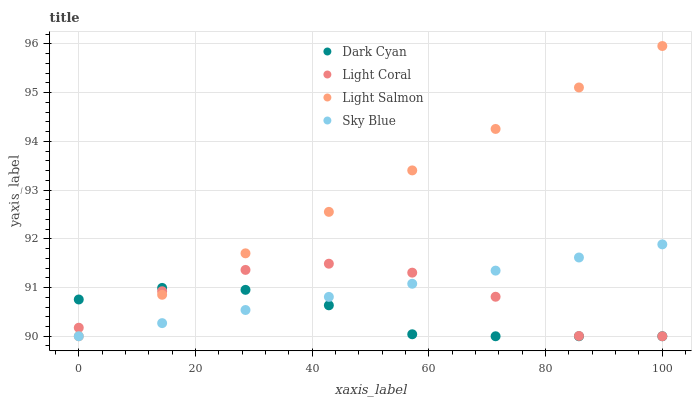Does Dark Cyan have the minimum area under the curve?
Answer yes or no. Yes. Does Light Salmon have the maximum area under the curve?
Answer yes or no. Yes. Does Light Coral have the minimum area under the curve?
Answer yes or no. No. Does Light Coral have the maximum area under the curve?
Answer yes or no. No. Is Sky Blue the smoothest?
Answer yes or no. Yes. Is Light Coral the roughest?
Answer yes or no. Yes. Is Light Salmon the smoothest?
Answer yes or no. No. Is Light Salmon the roughest?
Answer yes or no. No. Does Dark Cyan have the lowest value?
Answer yes or no. Yes. Does Light Salmon have the highest value?
Answer yes or no. Yes. Does Light Coral have the highest value?
Answer yes or no. No. Does Sky Blue intersect Dark Cyan?
Answer yes or no. Yes. Is Sky Blue less than Dark Cyan?
Answer yes or no. No. Is Sky Blue greater than Dark Cyan?
Answer yes or no. No. 